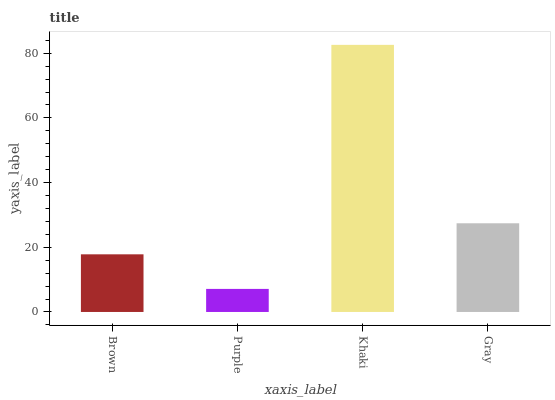Is Purple the minimum?
Answer yes or no. Yes. Is Khaki the maximum?
Answer yes or no. Yes. Is Khaki the minimum?
Answer yes or no. No. Is Purple the maximum?
Answer yes or no. No. Is Khaki greater than Purple?
Answer yes or no. Yes. Is Purple less than Khaki?
Answer yes or no. Yes. Is Purple greater than Khaki?
Answer yes or no. No. Is Khaki less than Purple?
Answer yes or no. No. Is Gray the high median?
Answer yes or no. Yes. Is Brown the low median?
Answer yes or no. Yes. Is Purple the high median?
Answer yes or no. No. Is Khaki the low median?
Answer yes or no. No. 